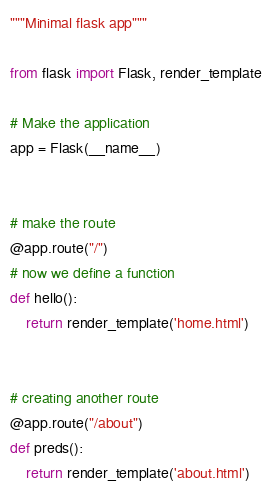<code> <loc_0><loc_0><loc_500><loc_500><_Python_>"""Minimal flask app"""

from flask import Flask, render_template

# Make the application
app = Flask(__name__)


# make the route
@app.route("/")
# now we define a function
def hello():
    return render_template('home.html')


# creating another route
@app.route("/about")
def preds():
    return render_template('about.html')
</code> 